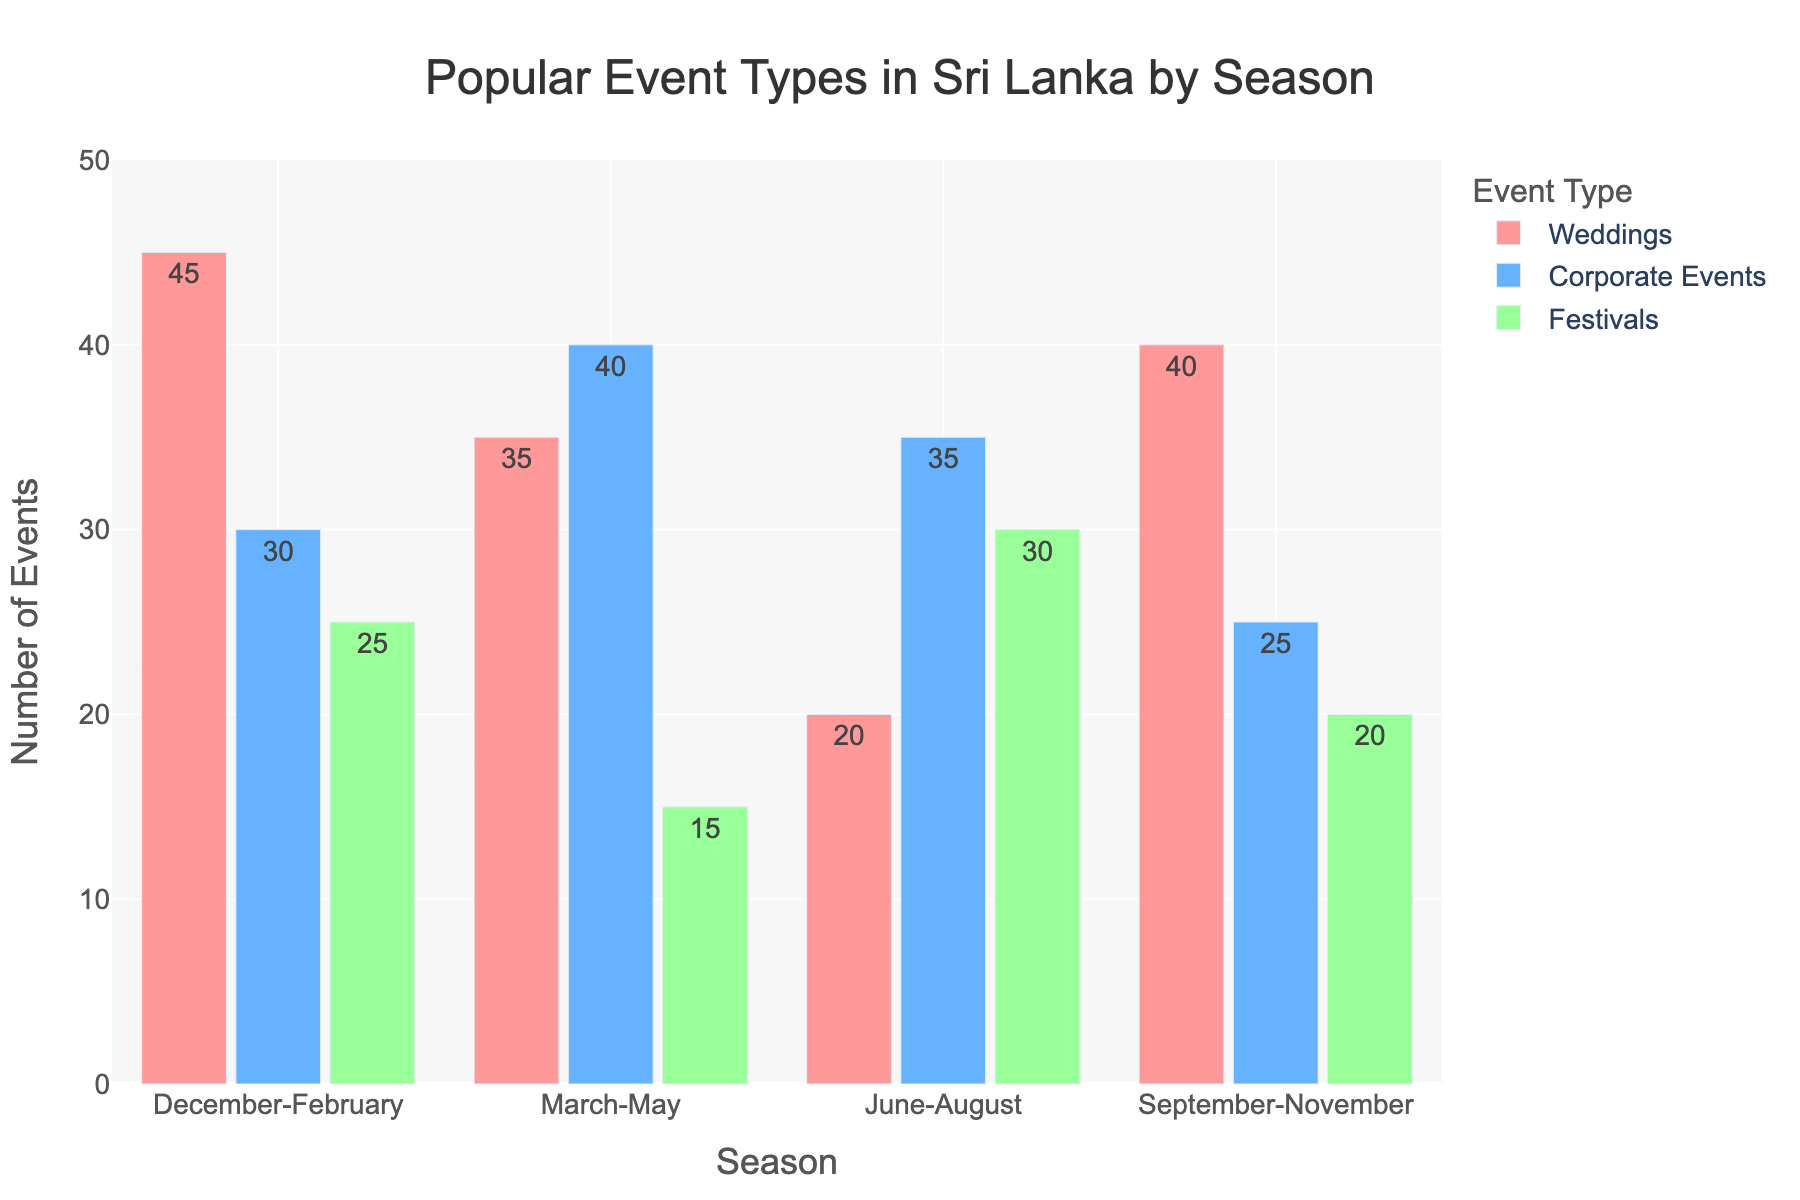What is the most popular event type in the December-February season? Weddings have the highest number of events with 45.
Answer: Weddings Which season has the highest number of corporate events? March-May has the highest number of corporate events with 40.
Answer: March-May How many more weddings are there in September-November compared to June-August? There are 40 weddings in September-November and 20 in June-August, so the difference is 40 - 20 = 20.
Answer: 20 What is the least popular event type in June-August? Weddings are the least popular in June-August with 20 events.
Answer: Weddings In which season do festivals occur most frequently? June-August has the highest number of festivals with 30.
Answer: June-August How many total events are there in December-February across all event types? Sum the number of weddings (45), corporate events (30), and festivals (25) in December-February: 45 + 30 + 25 = 100.
Answer: 100 Which event type is depicted in blue bars? Corporate Events are represented by blue bars.
Answer: Corporate Events During which season are weddings least popular? Weddings are least popular in June-August with 20 events.
Answer: June-August What is the total number of festivals from March-May and September-November combined? Sum the number of festivals in March-May (15) and September-November (20): 15 + 20 = 35.
Answer: 35 Which season has the smallest number of total events? This can be found by summing the events of all types per season and comparing:
- December-February: 45 + 30 + 25 = 100
- March-May: 35 + 40 + 15 = 90
- June-August: 20 + 35 + 30 = 85
- September-November: 40 + 25 + 20 = 85
June-August and September-November both have the smallest total, which is 85.
Answer: June-August, September-November 